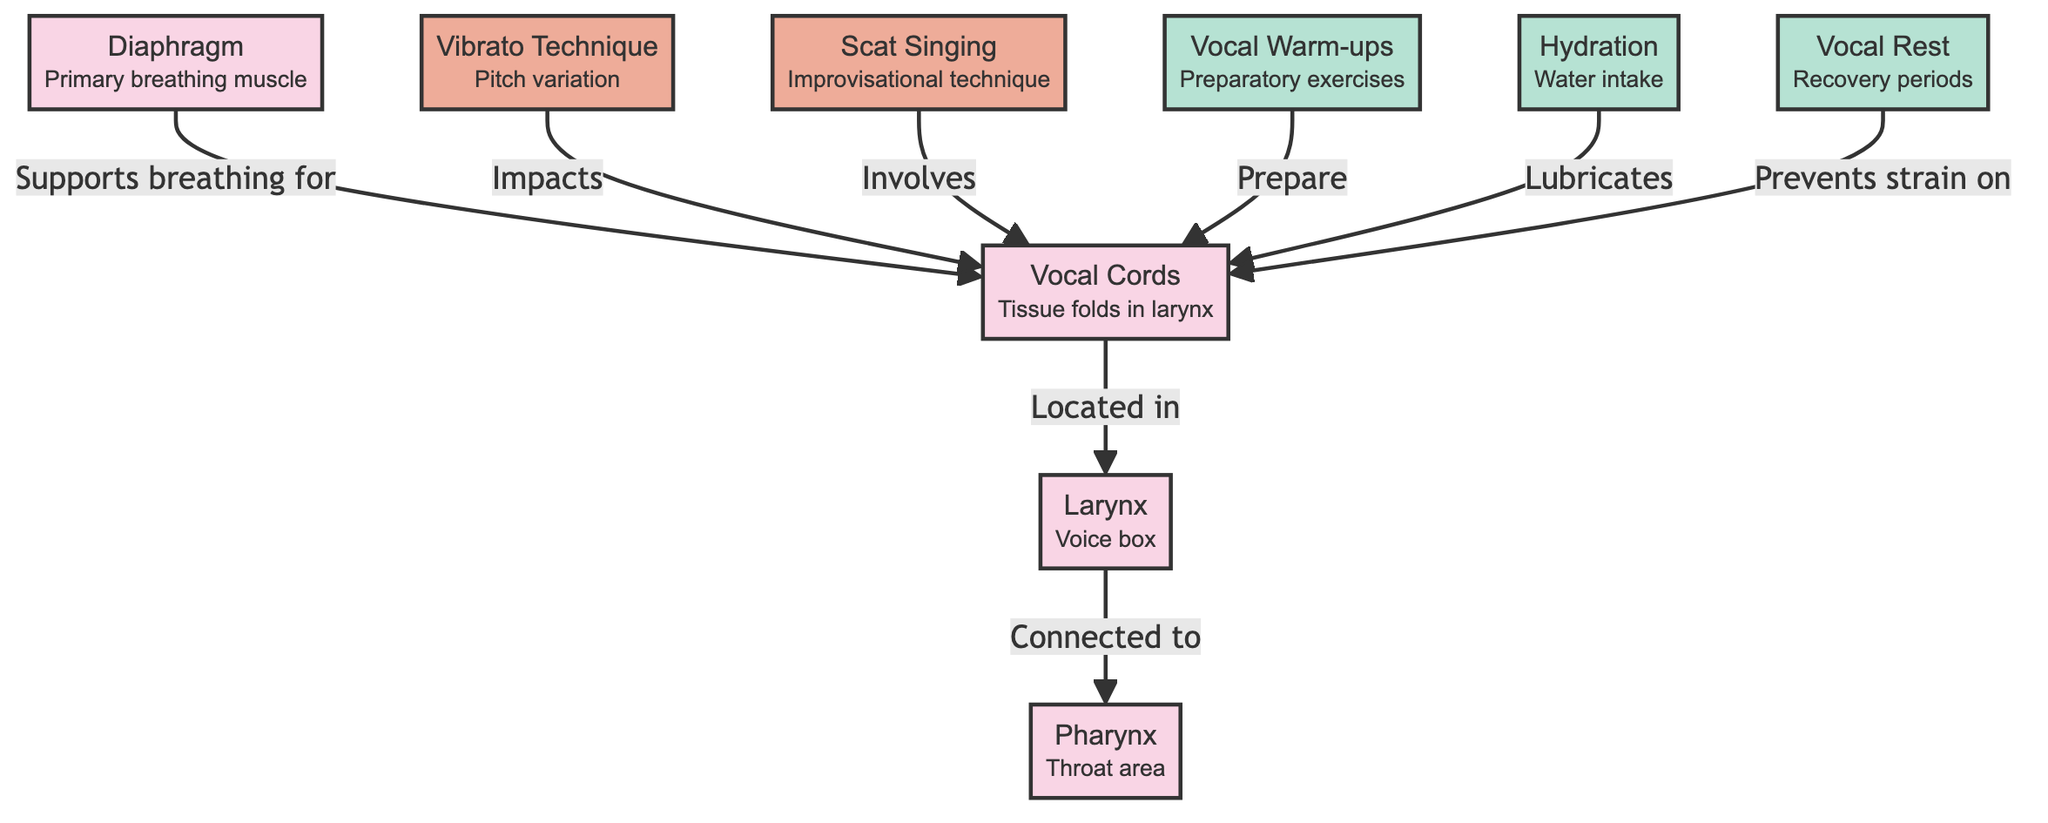What are the vocal cords located in? The diagram indicates that the vocal cords are located in the larynx, which is visually connected to the vocal cords node.
Answer: larynx Which technique impacts the vocal cords? The vibrato technique is shown to have an impact on the vocal cords according to the connection in the diagram.
Answer: vibrato technique How many care routines are listed? By counting the nodes categorized under care routines, there are three identified: vocal warm-ups, hydration, and vocal rest.
Answer: 3 What supports breathing for the vocal cords? The diaphragm is indicated in the diagram as the muscle that supports breathing for the vocal cords through its connection to the respective nodes.
Answer: diaphragm What prevents strain on the vocal cords? The diagram shows that vocal rest is the care routine that prevents strain on the vocal cords, as denoted by the connection.
Answer: vocal rest What does scat singing involve? The diagram connects scat singing directly to the vocal cords, indicating that this technique involves the vocal cords.
Answer: vocal cords Which node has a connection to hydration? Hydration connects to the vocal cords in the diagram, signifying that it plays a role in their maintenance.
Answer: vocal cords 